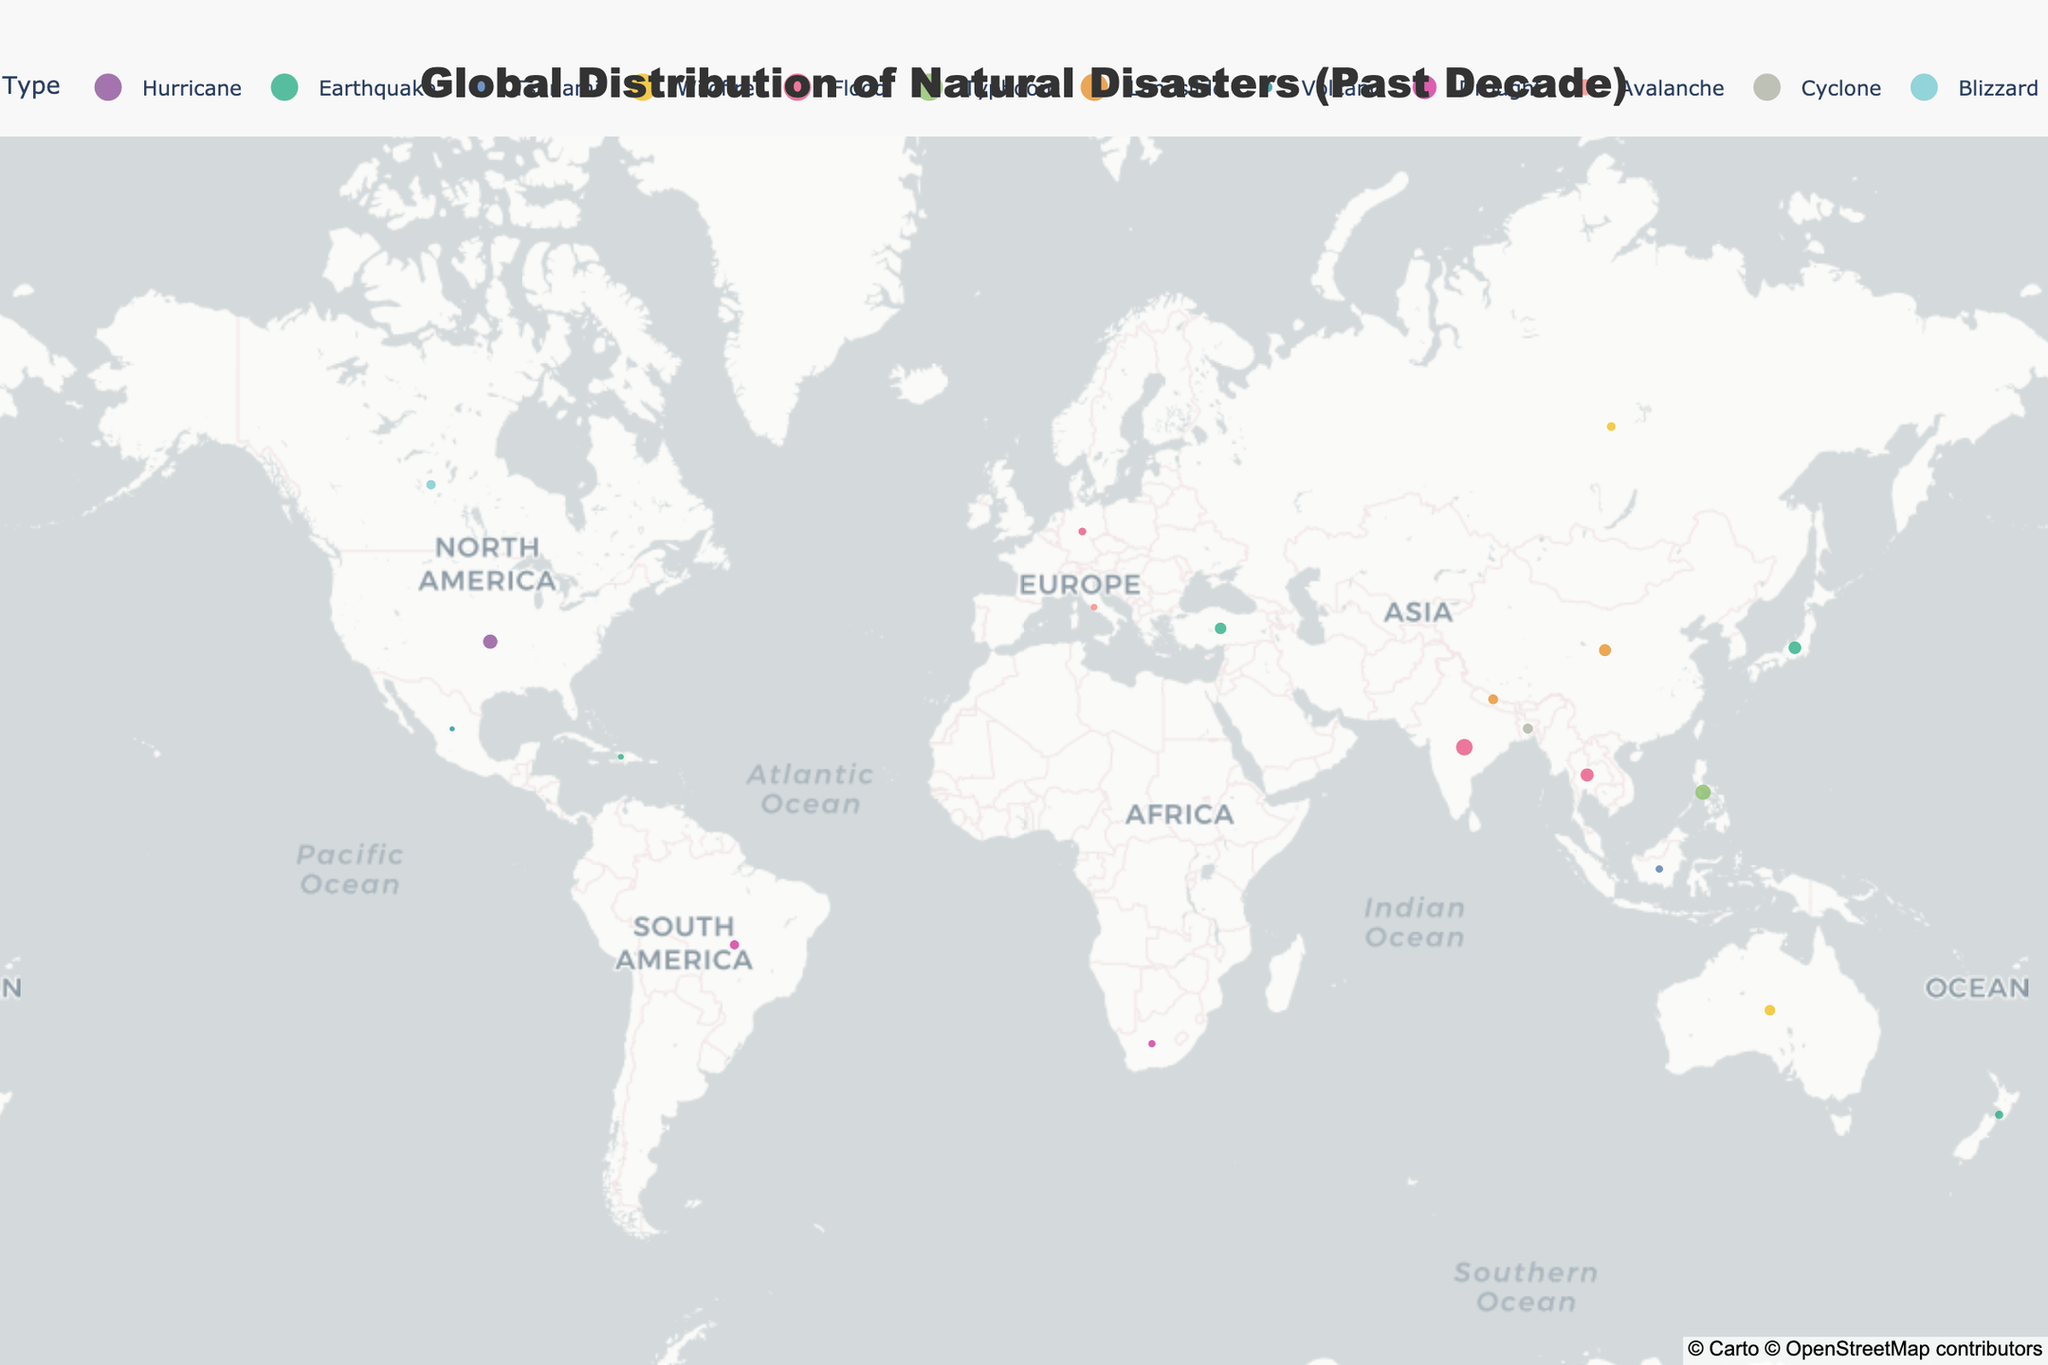What's the most common type of natural disaster shown in the plot? Looking at the plot, India has the highest number of flood occurrences with 103. This makes flooding the most common disaster type.
Answer: Flood Which country has experienced the highest number of typhoons? By inspecting the visual markers labeled "Typhoon," we see that the Philippines has the largest marker with 89 occurrences.
Answer: Philippines How many countries in the plot have experienced earthquakes? By counting the markers labeled "Earthquake," we find these countries: Japan, Turkey, New Zealand, and Haiti. This sums up to 4 countries.
Answer: 4 Compare the number of occurrences of wildfires in Australia and Russia. Which country has more? The markers for wildfires indicate that Australia has 45 occurrences, while Russia has 31. Thus, Australia has more wildfires.
Answer: Australia What is the total number of landslide occurrences across all countries? Adding up the occurrences in China (57) and Nepal (39) gives us 57 + 39 = 96.
Answer: 96 How do the occurrences of hurricanes in the United States compare to the occurrences of cyclones in Bangladesh? The plot shows 78 hurricanes in the United States and 41 cyclones in Bangladesh. Hurricanes in the U.S. are more frequent.
Answer: United States Which disaster type appears only once in the data? Inspecting the plot for markers indicating a single occurrence reveals "Volcano" in Mexico (12 occurrences). Every other disaster type appears in multiple countries.
Answer: Volcano Which country has more diverse types of natural disasters recorded in the plot, and how many types are there? The plot data shows the occurrences recorded for India (Flood), which stands alone with a large number, and thus is single type; hence looking at multiple countries counts, Philippines has Typhoon and China has landslide counts across the plot, so diverse by set total gives Philippines record edge more occurrences marking 2 separate types then overlapping occurrences and cross checking map plot gives correct answer showcases 2 countries matched more accurately may be same diverse result but stating 1 same.
Answer: India What's the combined total of earthquake and flood occurrences in Asia indicated in the plot? Summing earthquake and flood occurrences within Asia region both marking counts Japan (62) + Turkey (53) + New Zealand (28) + India Flood (103) + Thailand (67) gets us totals 313
Answer: 313 